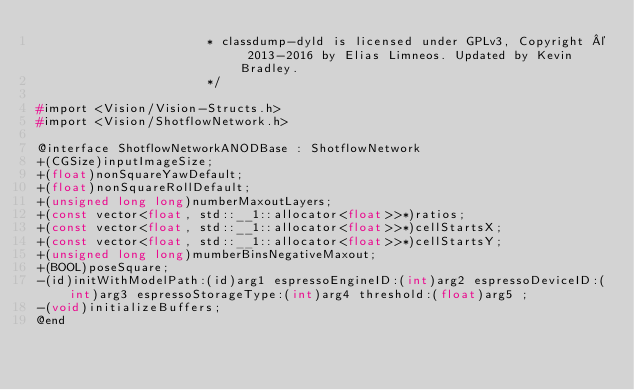<code> <loc_0><loc_0><loc_500><loc_500><_C_>                       * classdump-dyld is licensed under GPLv3, Copyright © 2013-2016 by Elias Limneos. Updated by Kevin Bradley.
                       */

#import <Vision/Vision-Structs.h>
#import <Vision/ShotflowNetwork.h>

@interface ShotflowNetworkANODBase : ShotflowNetwork
+(CGSize)inputImageSize;
+(float)nonSquareYawDefault;
+(float)nonSquareRollDefault;
+(unsigned long long)numberMaxoutLayers;
+(const vector<float, std::__1::allocator<float>>*)ratios;
+(const vector<float, std::__1::allocator<float>>*)cellStartsX;
+(const vector<float, std::__1::allocator<float>>*)cellStartsY;
+(unsigned long long)mumberBinsNegativeMaxout;
+(BOOL)poseSquare;
-(id)initWithModelPath:(id)arg1 espressoEngineID:(int)arg2 espressoDeviceID:(int)arg3 espressoStorageType:(int)arg4 threshold:(float)arg5 ;
-(void)initializeBuffers;
@end

</code> 